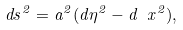<formula> <loc_0><loc_0><loc_500><loc_500>d s ^ { 2 } = a ^ { 2 } ( d \eta ^ { 2 } - d \ x ^ { 2 } ) ,</formula> 